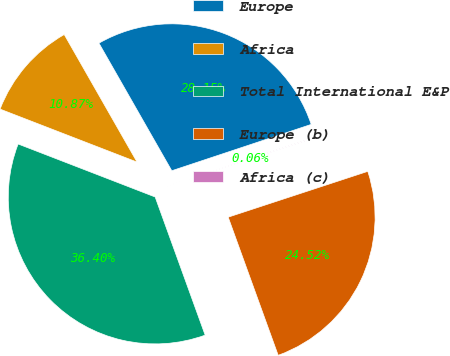Convert chart. <chart><loc_0><loc_0><loc_500><loc_500><pie_chart><fcel>Europe<fcel>Africa<fcel>Total International E&P<fcel>Europe (b)<fcel>Africa (c)<nl><fcel>28.15%<fcel>10.87%<fcel>36.4%<fcel>24.52%<fcel>0.06%<nl></chart> 